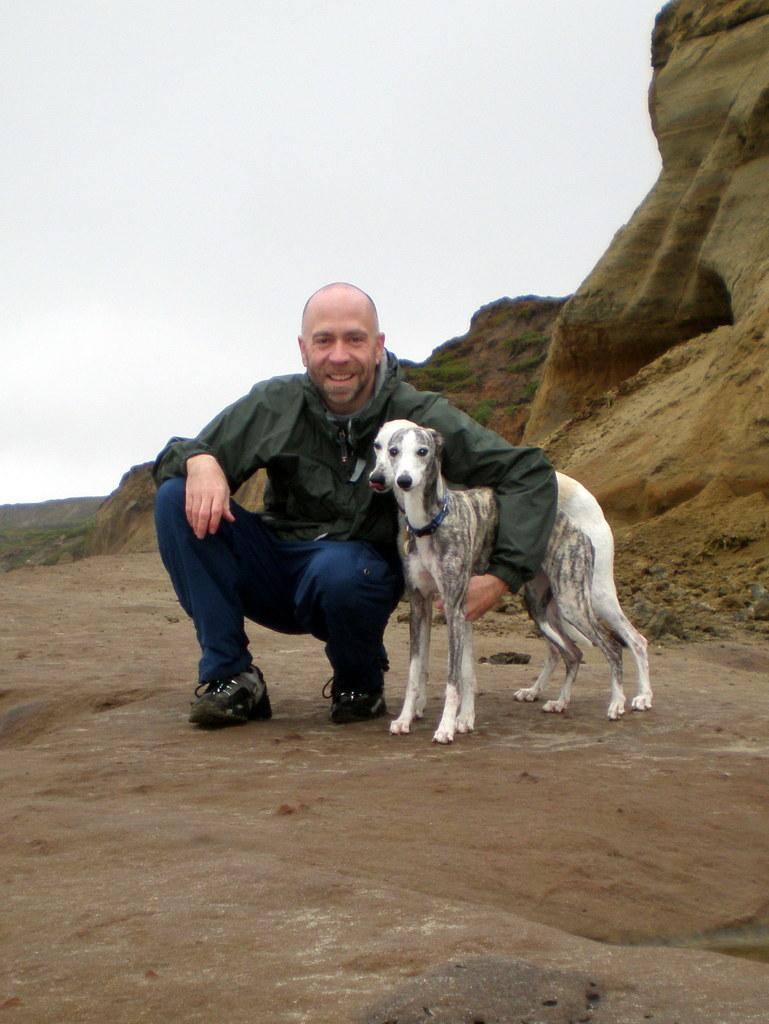Who is present in the image? There is a man in the image. What is the man doing in the image? The man is squatting on the land and holding two dogs with his hand. What can be seen in the background of the image? There is a hill and the sky visible in the background of the image. What type of pipe can be seen in the man's hand in the image? There is no pipe present in the man's hand or in the image. 